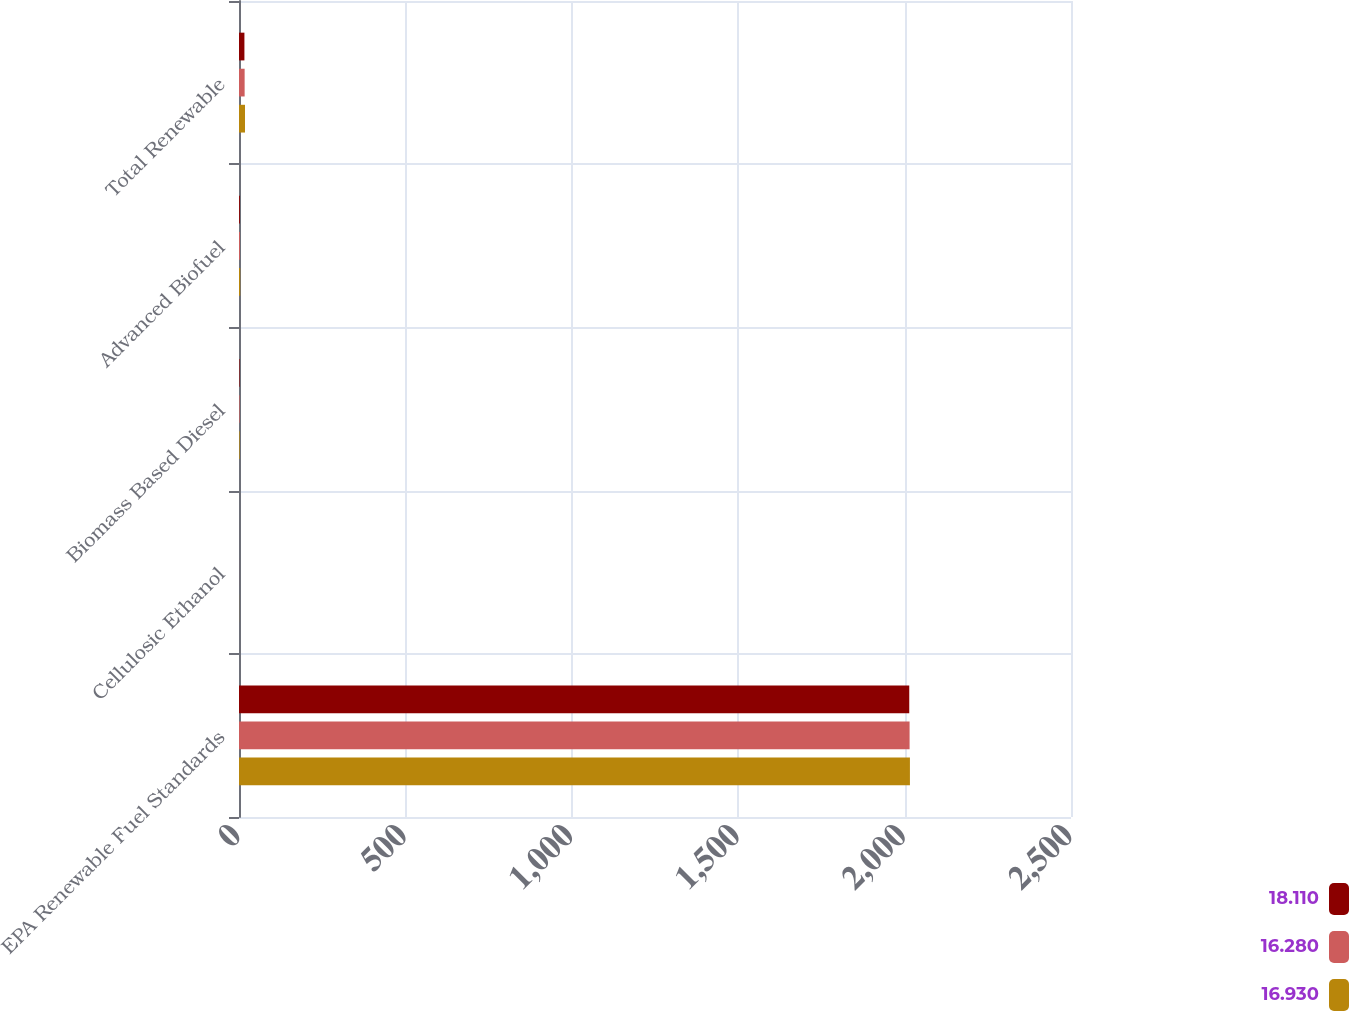Convert chart. <chart><loc_0><loc_0><loc_500><loc_500><stacked_bar_chart><ecel><fcel>EPA Renewable Fuel Standards<fcel>Cellulosic Ethanol<fcel>Biomass Based Diesel<fcel>Advanced Biofuel<fcel>Total Renewable<nl><fcel>18.11<fcel>2014<fcel>0.03<fcel>1.63<fcel>2.67<fcel>16.28<nl><fcel>16.28<fcel>2015<fcel>0.12<fcel>1.73<fcel>2.88<fcel>16.93<nl><fcel>16.93<fcel>2016<fcel>0.23<fcel>1.9<fcel>3.61<fcel>18.11<nl></chart> 